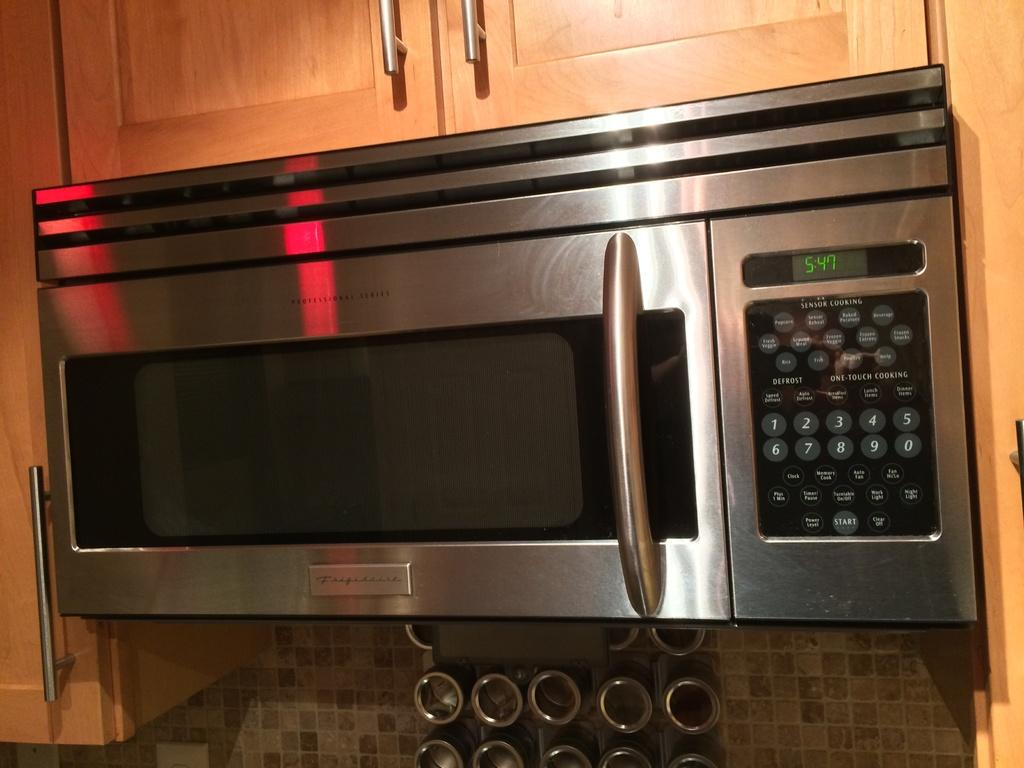Provide a one-sentence caption for the provided image. A shiny, clean kitchen microwave shows the time as 5:47. 